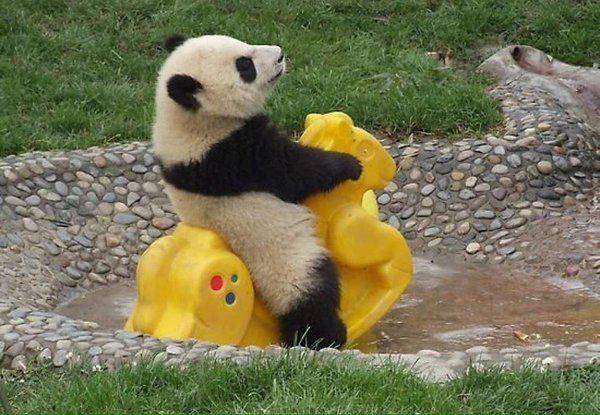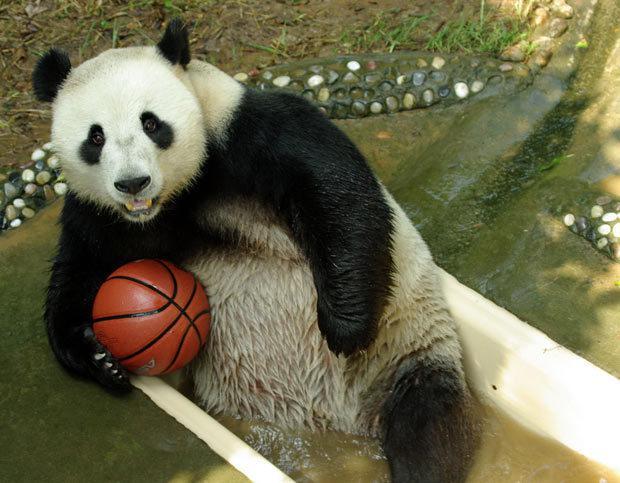The first image is the image on the left, the second image is the image on the right. Given the left and right images, does the statement "One image shows at least one panda on top of bright yellow plastic playground equipment." hold true? Answer yes or no. Yes. The first image is the image on the left, the second image is the image on the right. For the images displayed, is the sentence "The right image contains exactly two pandas." factually correct? Answer yes or no. No. 